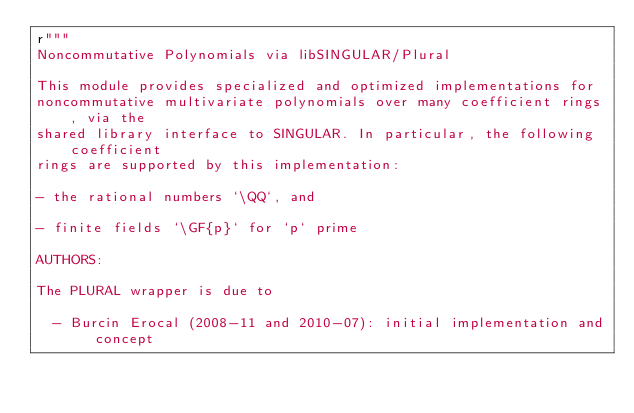<code> <loc_0><loc_0><loc_500><loc_500><_Cython_>r"""
Noncommutative Polynomials via libSINGULAR/Plural

This module provides specialized and optimized implementations for
noncommutative multivariate polynomials over many coefficient rings, via the
shared library interface to SINGULAR. In particular, the following coefficient
rings are supported by this implementation:

- the rational numbers `\QQ`, and

- finite fields `\GF{p}` for `p` prime

AUTHORS:

The PLURAL wrapper is due to

  - Burcin Erocal (2008-11 and 2010-07): initial implementation and concept
</code> 